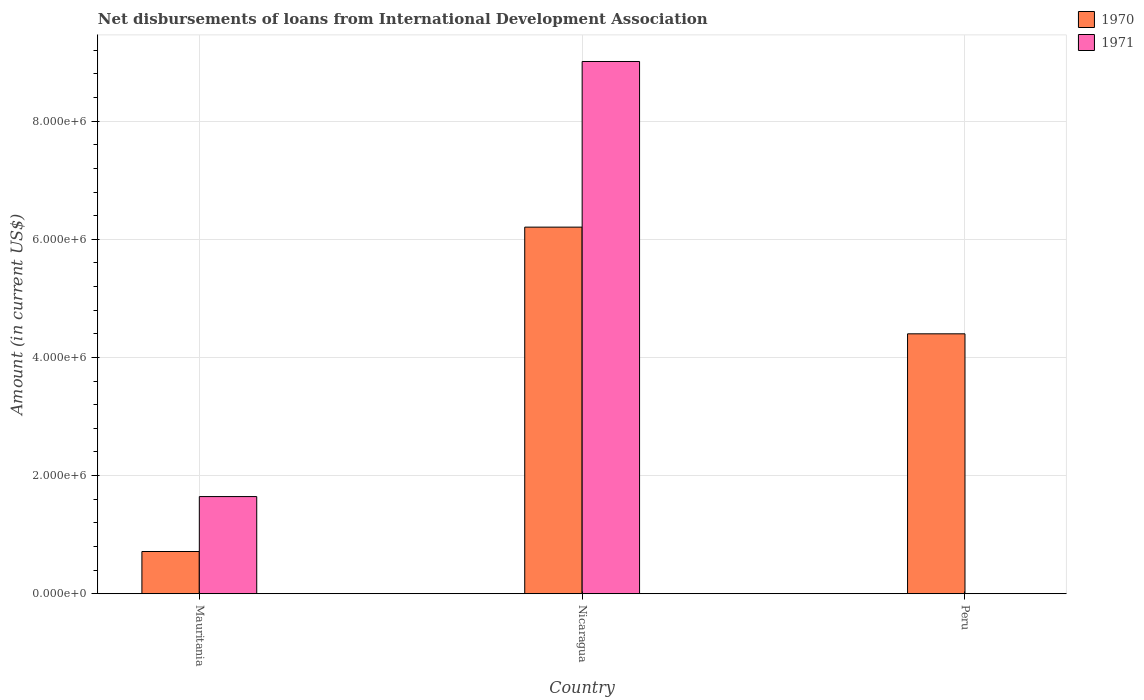Are the number of bars per tick equal to the number of legend labels?
Make the answer very short. No. Are the number of bars on each tick of the X-axis equal?
Keep it short and to the point. No. What is the label of the 1st group of bars from the left?
Your answer should be very brief. Mauritania. In how many cases, is the number of bars for a given country not equal to the number of legend labels?
Provide a short and direct response. 1. Across all countries, what is the maximum amount of loans disbursed in 1970?
Give a very brief answer. 6.21e+06. Across all countries, what is the minimum amount of loans disbursed in 1971?
Offer a terse response. 0. In which country was the amount of loans disbursed in 1971 maximum?
Offer a terse response. Nicaragua. What is the total amount of loans disbursed in 1971 in the graph?
Your response must be concise. 1.07e+07. What is the difference between the amount of loans disbursed in 1971 in Mauritania and that in Nicaragua?
Your answer should be compact. -7.36e+06. What is the difference between the amount of loans disbursed in 1971 in Nicaragua and the amount of loans disbursed in 1970 in Peru?
Make the answer very short. 4.61e+06. What is the average amount of loans disbursed in 1971 per country?
Make the answer very short. 3.55e+06. What is the difference between the amount of loans disbursed of/in 1971 and amount of loans disbursed of/in 1970 in Nicaragua?
Give a very brief answer. 2.80e+06. What is the ratio of the amount of loans disbursed in 1971 in Mauritania to that in Nicaragua?
Give a very brief answer. 0.18. What is the difference between the highest and the second highest amount of loans disbursed in 1970?
Give a very brief answer. 5.49e+06. What is the difference between the highest and the lowest amount of loans disbursed in 1971?
Make the answer very short. 9.01e+06. In how many countries, is the amount of loans disbursed in 1970 greater than the average amount of loans disbursed in 1970 taken over all countries?
Offer a terse response. 2. How many bars are there?
Your answer should be compact. 5. How many countries are there in the graph?
Offer a terse response. 3. What is the difference between two consecutive major ticks on the Y-axis?
Your answer should be very brief. 2.00e+06. Does the graph contain grids?
Offer a terse response. Yes. What is the title of the graph?
Offer a terse response. Net disbursements of loans from International Development Association. What is the label or title of the X-axis?
Offer a terse response. Country. What is the label or title of the Y-axis?
Provide a short and direct response. Amount (in current US$). What is the Amount (in current US$) in 1970 in Mauritania?
Make the answer very short. 7.15e+05. What is the Amount (in current US$) in 1971 in Mauritania?
Provide a short and direct response. 1.64e+06. What is the Amount (in current US$) of 1970 in Nicaragua?
Provide a short and direct response. 6.21e+06. What is the Amount (in current US$) in 1971 in Nicaragua?
Keep it short and to the point. 9.01e+06. What is the Amount (in current US$) in 1970 in Peru?
Ensure brevity in your answer.  4.40e+06. What is the Amount (in current US$) in 1971 in Peru?
Ensure brevity in your answer.  0. Across all countries, what is the maximum Amount (in current US$) of 1970?
Provide a short and direct response. 6.21e+06. Across all countries, what is the maximum Amount (in current US$) in 1971?
Provide a short and direct response. 9.01e+06. Across all countries, what is the minimum Amount (in current US$) in 1970?
Give a very brief answer. 7.15e+05. Across all countries, what is the minimum Amount (in current US$) of 1971?
Provide a succinct answer. 0. What is the total Amount (in current US$) of 1970 in the graph?
Keep it short and to the point. 1.13e+07. What is the total Amount (in current US$) in 1971 in the graph?
Provide a succinct answer. 1.07e+07. What is the difference between the Amount (in current US$) of 1970 in Mauritania and that in Nicaragua?
Ensure brevity in your answer.  -5.49e+06. What is the difference between the Amount (in current US$) in 1971 in Mauritania and that in Nicaragua?
Ensure brevity in your answer.  -7.36e+06. What is the difference between the Amount (in current US$) of 1970 in Mauritania and that in Peru?
Your response must be concise. -3.68e+06. What is the difference between the Amount (in current US$) in 1970 in Nicaragua and that in Peru?
Ensure brevity in your answer.  1.81e+06. What is the difference between the Amount (in current US$) of 1970 in Mauritania and the Amount (in current US$) of 1971 in Nicaragua?
Give a very brief answer. -8.30e+06. What is the average Amount (in current US$) of 1970 per country?
Ensure brevity in your answer.  3.77e+06. What is the average Amount (in current US$) in 1971 per country?
Offer a terse response. 3.55e+06. What is the difference between the Amount (in current US$) of 1970 and Amount (in current US$) of 1971 in Mauritania?
Offer a terse response. -9.30e+05. What is the difference between the Amount (in current US$) of 1970 and Amount (in current US$) of 1971 in Nicaragua?
Your response must be concise. -2.80e+06. What is the ratio of the Amount (in current US$) of 1970 in Mauritania to that in Nicaragua?
Your answer should be very brief. 0.12. What is the ratio of the Amount (in current US$) of 1971 in Mauritania to that in Nicaragua?
Ensure brevity in your answer.  0.18. What is the ratio of the Amount (in current US$) of 1970 in Mauritania to that in Peru?
Provide a short and direct response. 0.16. What is the ratio of the Amount (in current US$) of 1970 in Nicaragua to that in Peru?
Your answer should be compact. 1.41. What is the difference between the highest and the second highest Amount (in current US$) in 1970?
Your answer should be compact. 1.81e+06. What is the difference between the highest and the lowest Amount (in current US$) of 1970?
Give a very brief answer. 5.49e+06. What is the difference between the highest and the lowest Amount (in current US$) in 1971?
Provide a succinct answer. 9.01e+06. 